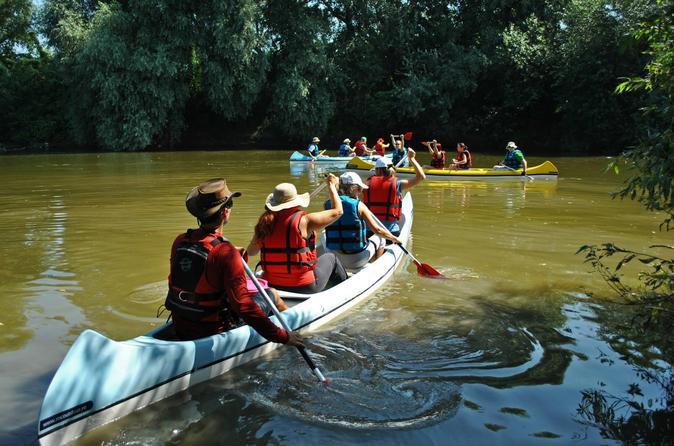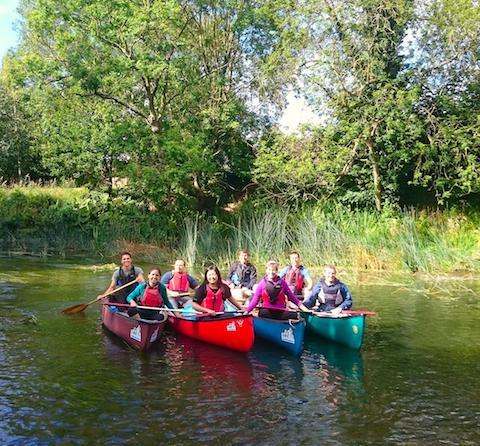The first image is the image on the left, the second image is the image on the right. Considering the images on both sides, is "There is more than one canoe in each image." valid? Answer yes or no. Yes. The first image is the image on the left, the second image is the image on the right. Evaluate the accuracy of this statement regarding the images: "The right image features multiple canoes heading forward at a right angle that are not aligned side-by-side.". Is it true? Answer yes or no. No. 